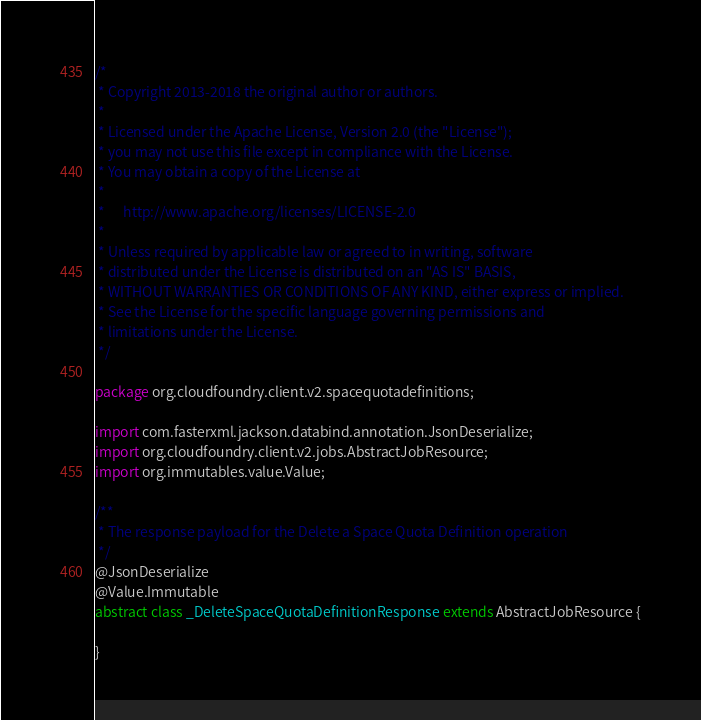<code> <loc_0><loc_0><loc_500><loc_500><_Java_>/*
 * Copyright 2013-2018 the original author or authors.
 *
 * Licensed under the Apache License, Version 2.0 (the "License");
 * you may not use this file except in compliance with the License.
 * You may obtain a copy of the License at
 *
 *      http://www.apache.org/licenses/LICENSE-2.0
 *
 * Unless required by applicable law or agreed to in writing, software
 * distributed under the License is distributed on an "AS IS" BASIS,
 * WITHOUT WARRANTIES OR CONDITIONS OF ANY KIND, either express or implied.
 * See the License for the specific language governing permissions and
 * limitations under the License.
 */

package org.cloudfoundry.client.v2.spacequotadefinitions;

import com.fasterxml.jackson.databind.annotation.JsonDeserialize;
import org.cloudfoundry.client.v2.jobs.AbstractJobResource;
import org.immutables.value.Value;

/**
 * The response payload for the Delete a Space Quota Definition operation
 */
@JsonDeserialize
@Value.Immutable
abstract class _DeleteSpaceQuotaDefinitionResponse extends AbstractJobResource {

}
</code> 